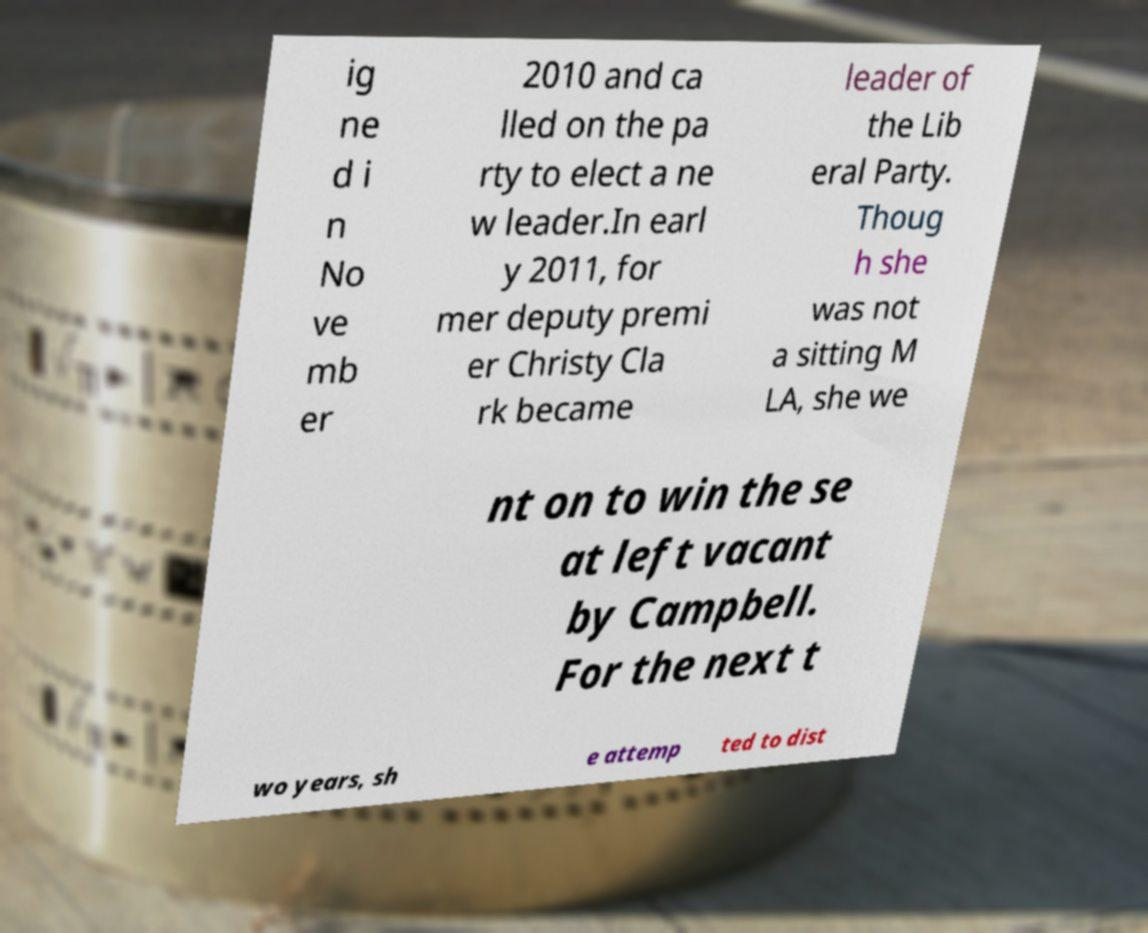There's text embedded in this image that I need extracted. Can you transcribe it verbatim? ig ne d i n No ve mb er 2010 and ca lled on the pa rty to elect a ne w leader.In earl y 2011, for mer deputy premi er Christy Cla rk became leader of the Lib eral Party. Thoug h she was not a sitting M LA, she we nt on to win the se at left vacant by Campbell. For the next t wo years, sh e attemp ted to dist 